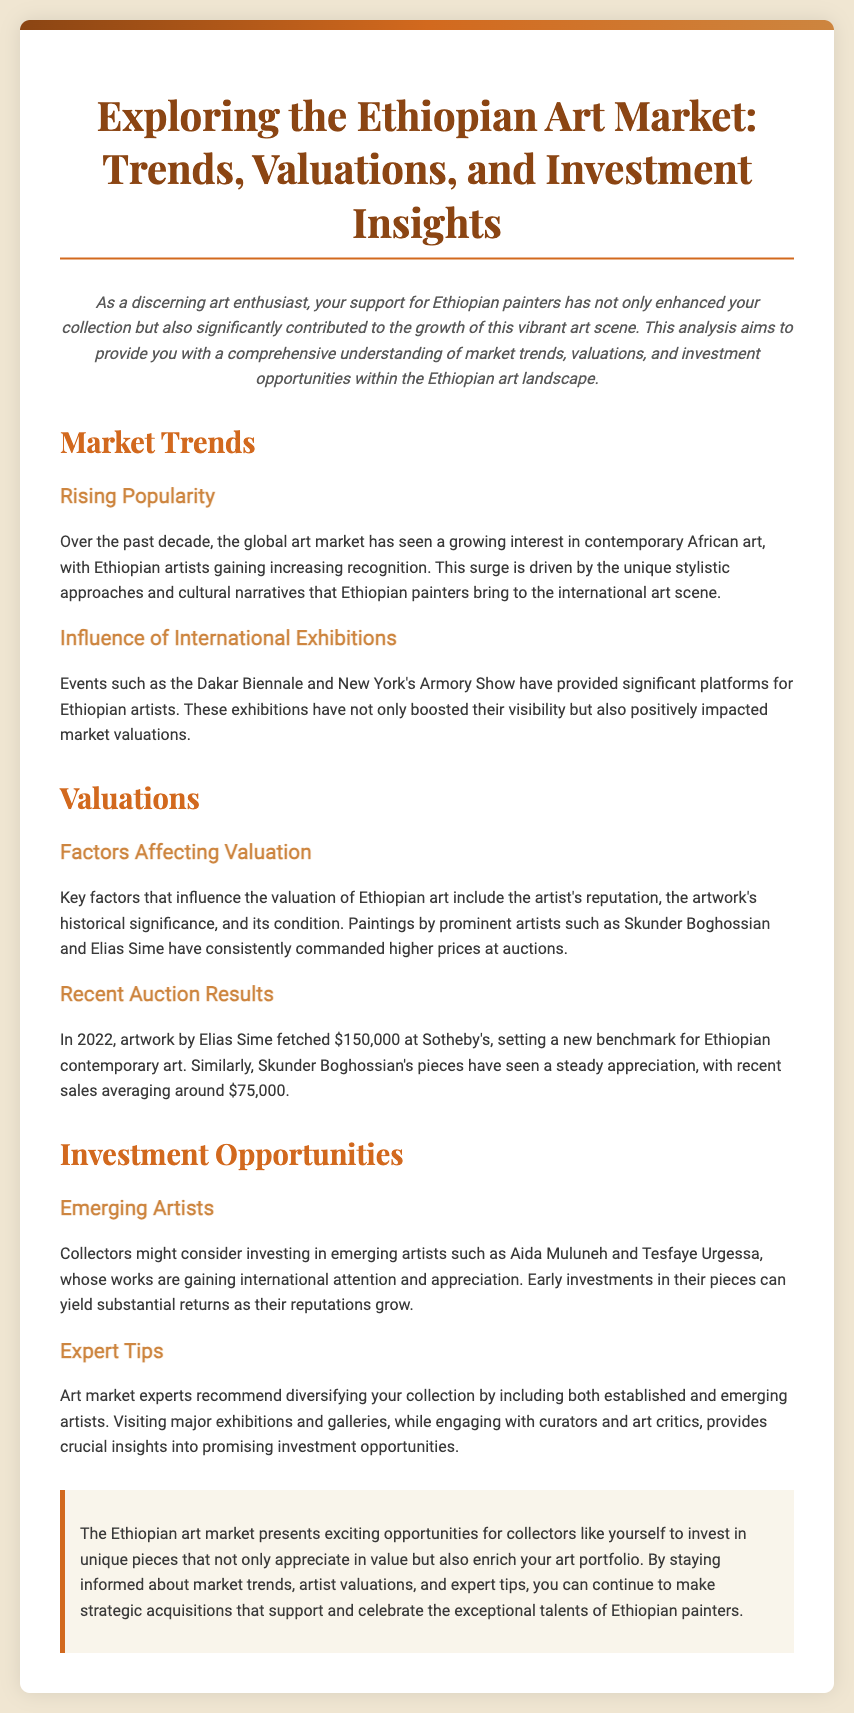What is the title of the document? The title of the document is provided at the beginning in the header section.
Answer: Exploring the Ethiopian Art Market: Trends, Valuations, and Investment Insights Who is a prominent artist mentioned that commands high prices? The document lists specific artists that have notable valuations.
Answer: Skunder Boghossian What was the auction price for Elias Sime's artwork in 2022? The document specifies the auction result as a significant figure related to Elias Sime's artwork.
Answer: $150,000 Which exhibition positively impacted Ethiopian artists' market valuations? The document names major exhibitions that have enhanced the visibility of Ethiopian artists.
Answer: Dakar Biennale What is one recommended strategy for collectors? The document provides expert tips on approaches collectors should consider regarding their art investments.
Answer: Diversifying your collection What type of art market trends does the document discuss? The document explores various themes related to market trends for Ethiopian art.
Answer: Rising Popularity Which emerging artist is highlighted for potential investment opportunities? The document identifies new artists to watch for investment within the Ethiopian art scene.
Answer: Aida Muluneh What year did the artwork auction by Elias Sime take place? The specific date of an auction event is detailed in the document.
Answer: 2022 What color is primarily used for the heading of the conclusion section? The document describes the visual design elements, including color usage.
Answer: Light beige 